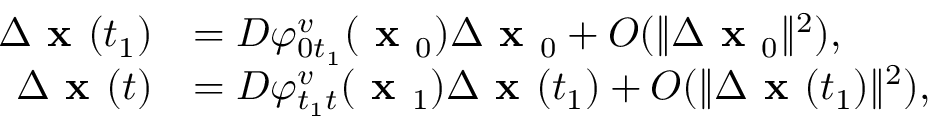Convert formula to latex. <formula><loc_0><loc_0><loc_500><loc_500>\begin{array} { r l } { \Delta x ( t _ { 1 } ) } & { = D \varphi _ { 0 t _ { 1 } } ^ { v } ( x _ { 0 } ) \Delta x _ { 0 } + O ( \| \Delta x _ { 0 } \| ^ { 2 } ) , } \\ { \Delta x ( t ) } & { = D \varphi _ { t _ { 1 } t } ^ { v } ( x _ { 1 } ) \Delta x ( t _ { 1 } ) + O ( \| \Delta x ( t _ { 1 } ) \| ^ { 2 } ) , } \end{array}</formula> 